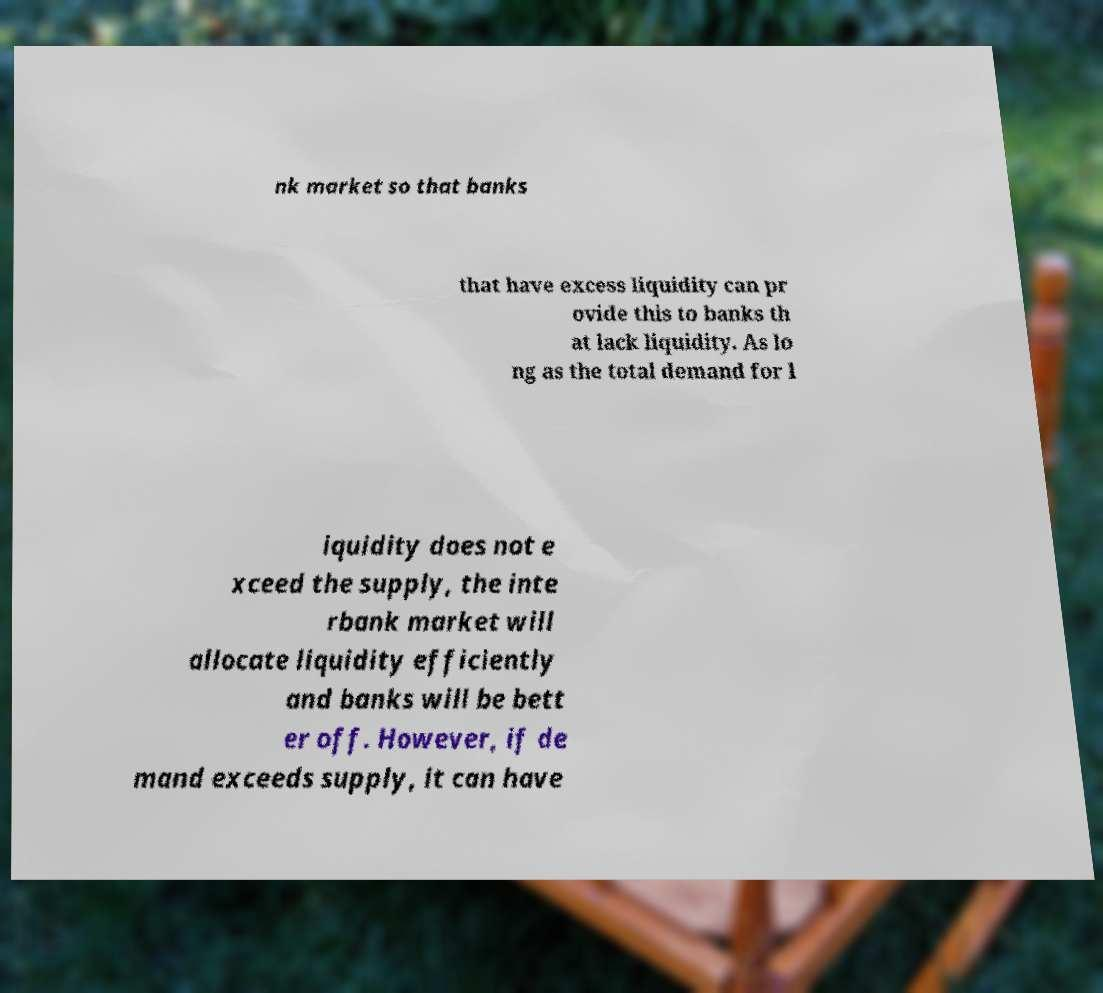Could you extract and type out the text from this image? nk market so that banks that have excess liquidity can pr ovide this to banks th at lack liquidity. As lo ng as the total demand for l iquidity does not e xceed the supply, the inte rbank market will allocate liquidity efficiently and banks will be bett er off. However, if de mand exceeds supply, it can have 